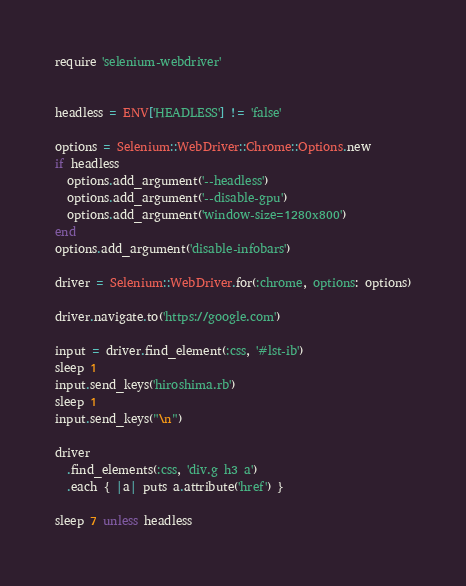Convert code to text. <code><loc_0><loc_0><loc_500><loc_500><_Ruby_>
require 'selenium-webdriver'


headless = ENV['HEADLESS'] != 'false'

options = Selenium::WebDriver::Chrome::Options.new
if headless
  options.add_argument('--headless')
  options.add_argument('--disable-gpu')
  options.add_argument('window-size=1280x800')
end
options.add_argument('disable-infobars')

driver = Selenium::WebDriver.for(:chrome, options: options)

driver.navigate.to('https://google.com')

input = driver.find_element(:css, '#lst-ib')
sleep 1
input.send_keys('hiroshima.rb')
sleep 1
input.send_keys("\n")

driver
  .find_elements(:css, 'div.g h3 a')
  .each { |a| puts a.attribute('href') }

sleep 7 unless headless

</code> 